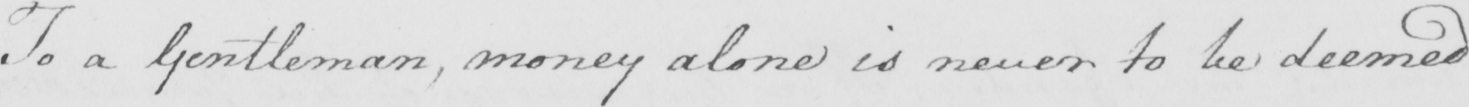What is written in this line of handwriting? To a gentleman , money alone is never to be deemed 